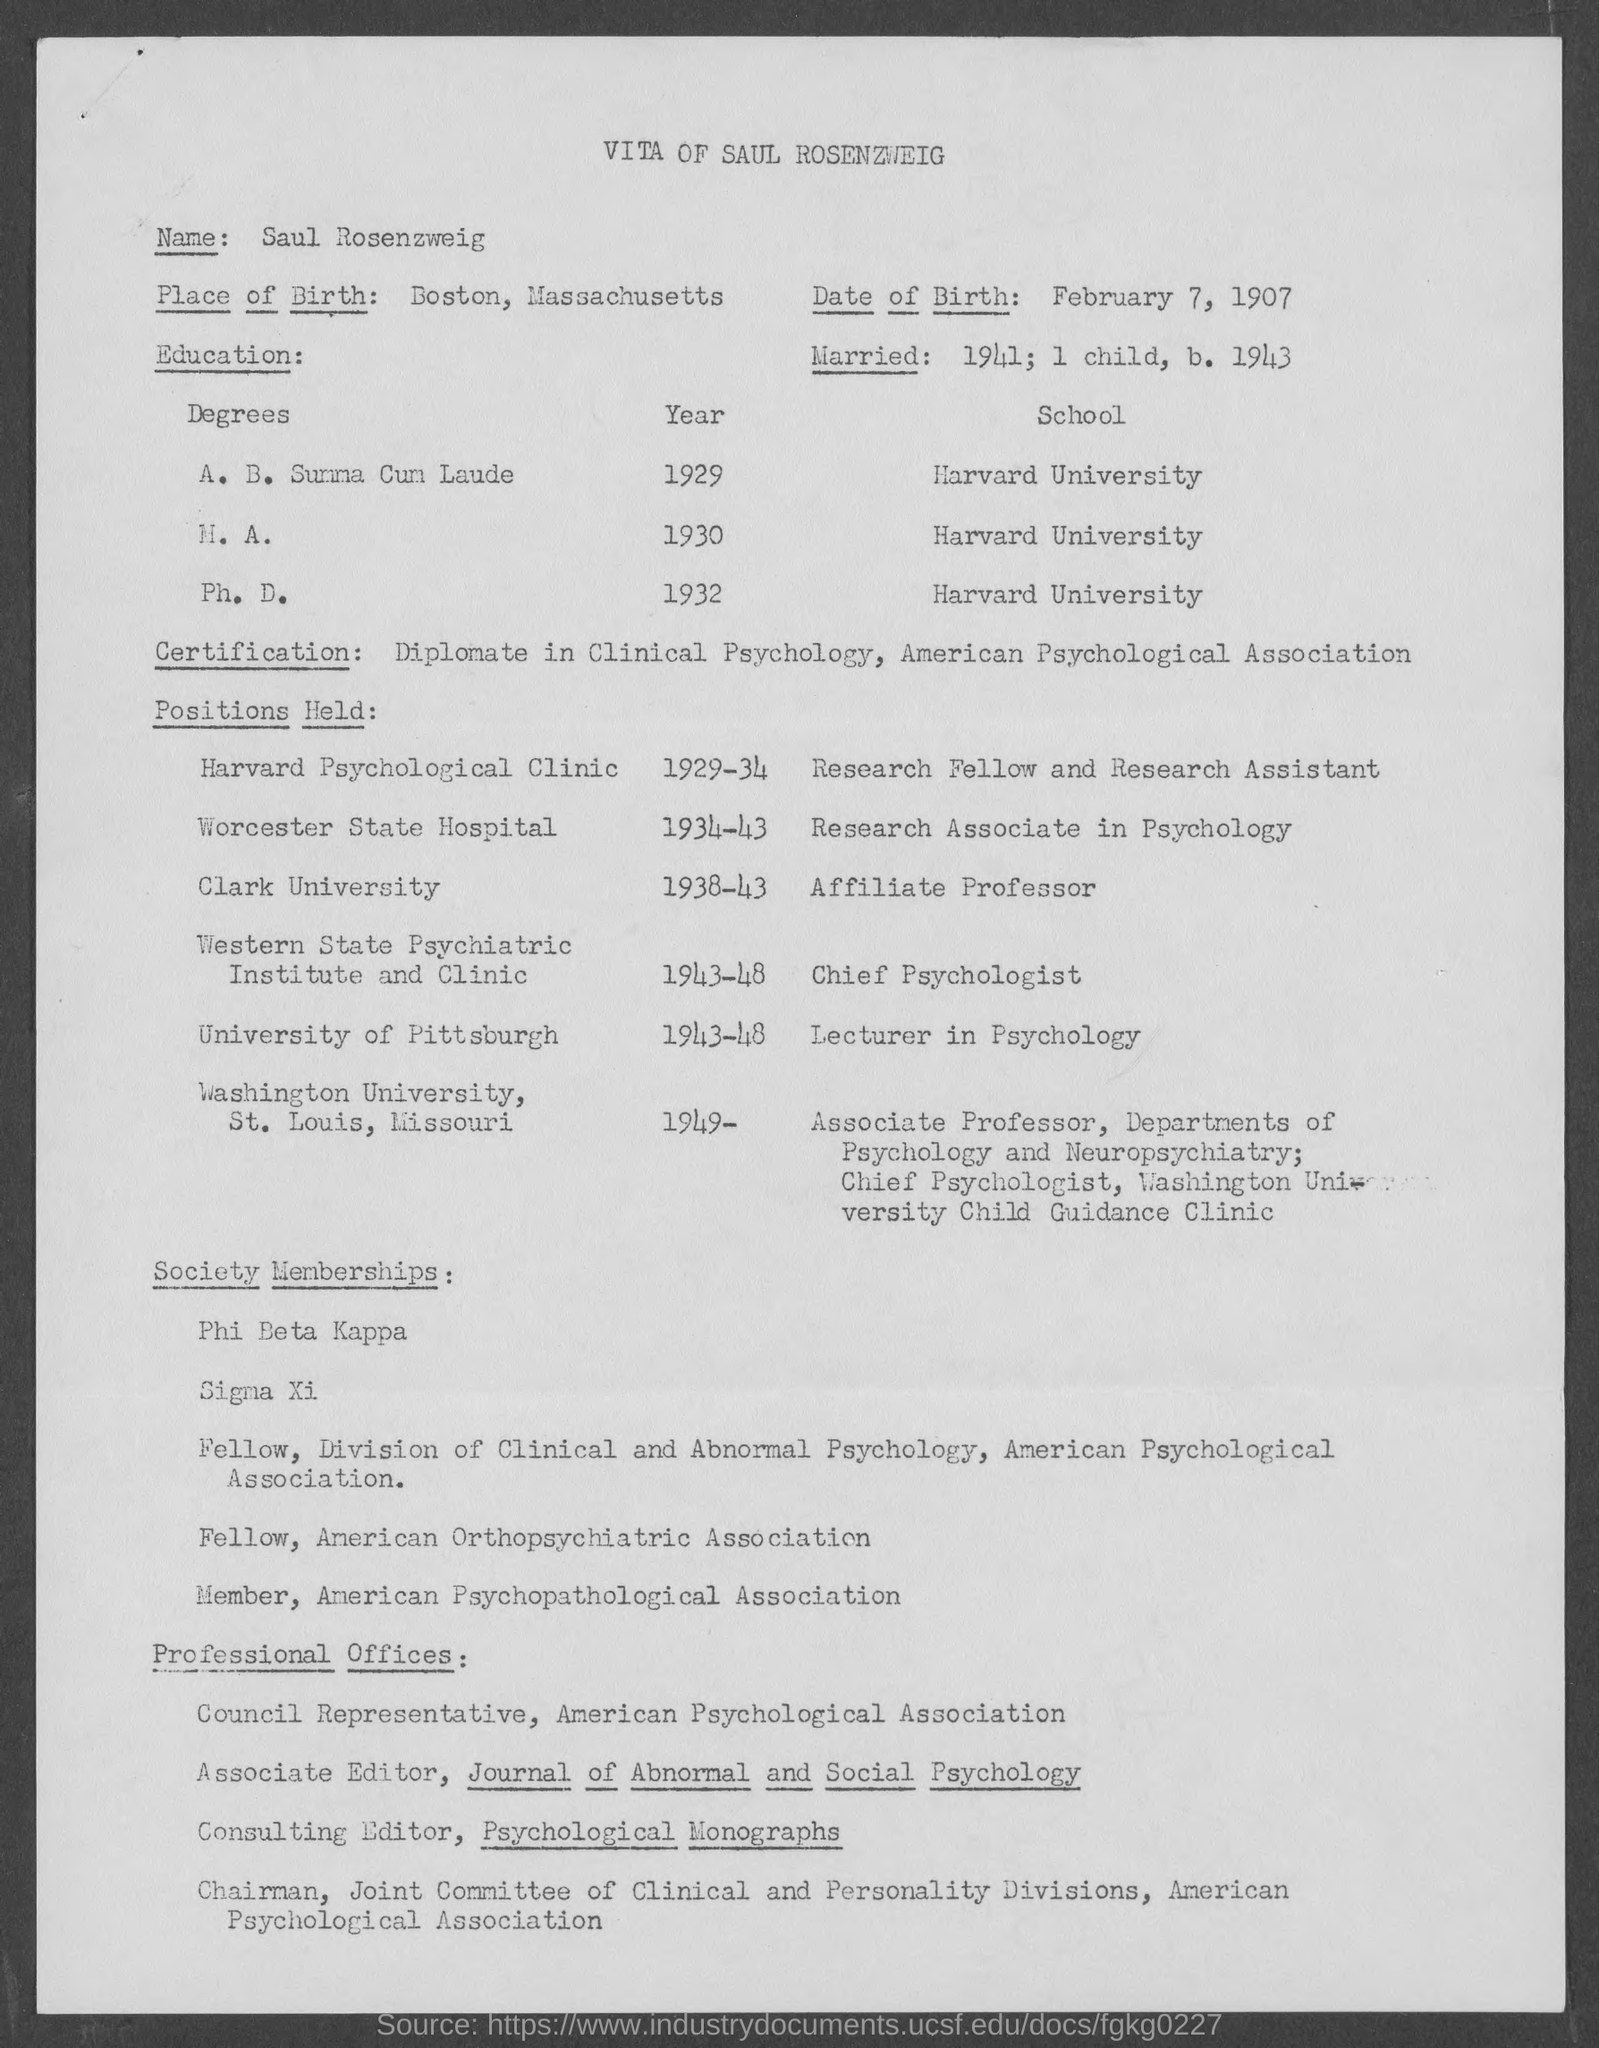Can you tell me more about this person's educational background? Certainly! The individual in the document attended Harvard University, where he graduated Summa Cum Laude with an A.B. in 1929, received his M.A. in 1930, and then completed his Ph.D. in 1932. 